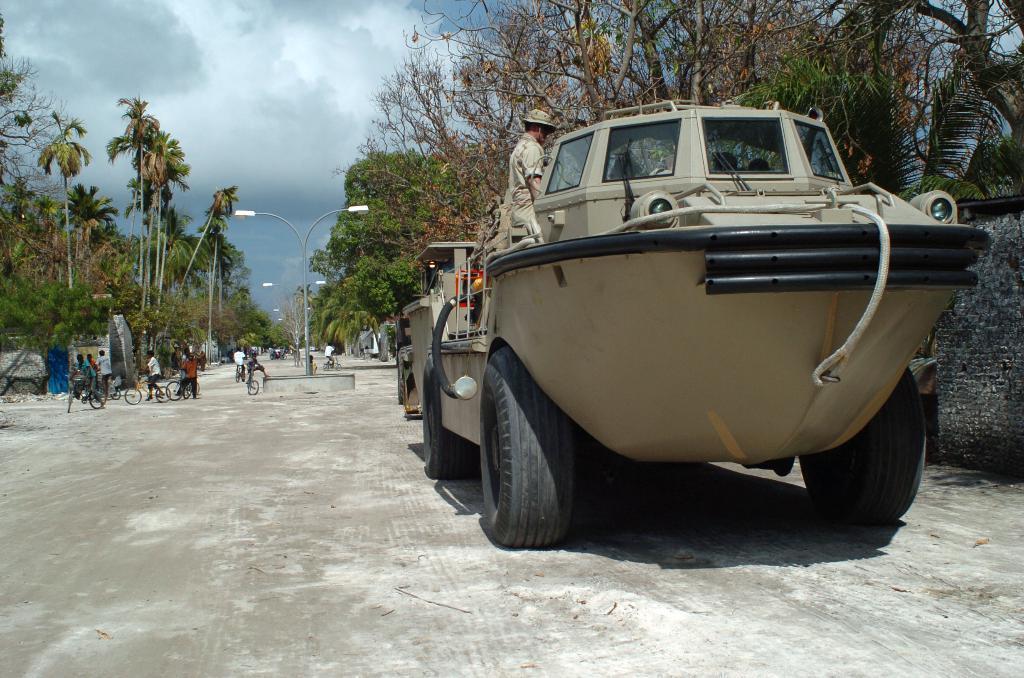Please provide a concise description of this image. In this picture we can see a person in a vehicle, few vehicles are on the road, behind we can see trees and houses. 